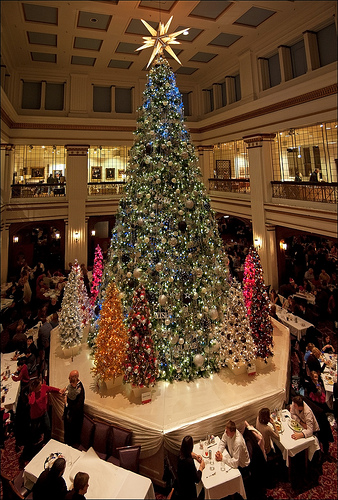<image>
Can you confirm if the building is behind the lights? Yes. From this viewpoint, the building is positioned behind the lights, with the lights partially or fully occluding the building. 